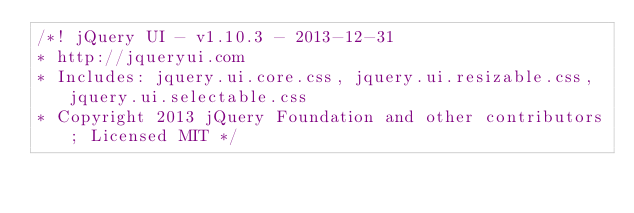Convert code to text. <code><loc_0><loc_0><loc_500><loc_500><_CSS_>/*! jQuery UI - v1.10.3 - 2013-12-31
* http://jqueryui.com
* Includes: jquery.ui.core.css, jquery.ui.resizable.css, jquery.ui.selectable.css
* Copyright 2013 jQuery Foundation and other contributors; Licensed MIT */
</code> 